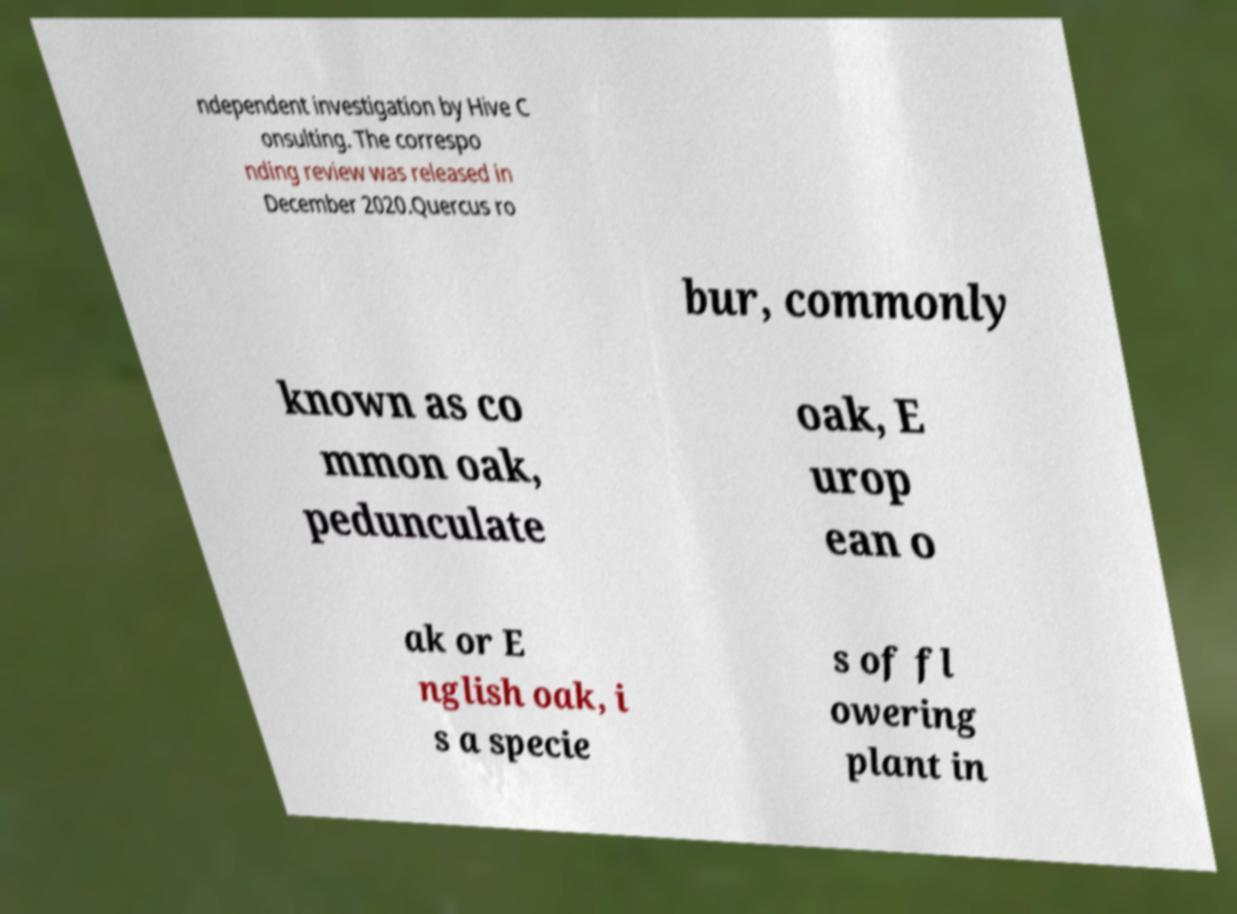What messages or text are displayed in this image? I need them in a readable, typed format. ndependent investigation by Hive C onsulting. The correspo nding review was released in December 2020.Quercus ro bur, commonly known as co mmon oak, pedunculate oak, E urop ean o ak or E nglish oak, i s a specie s of fl owering plant in 